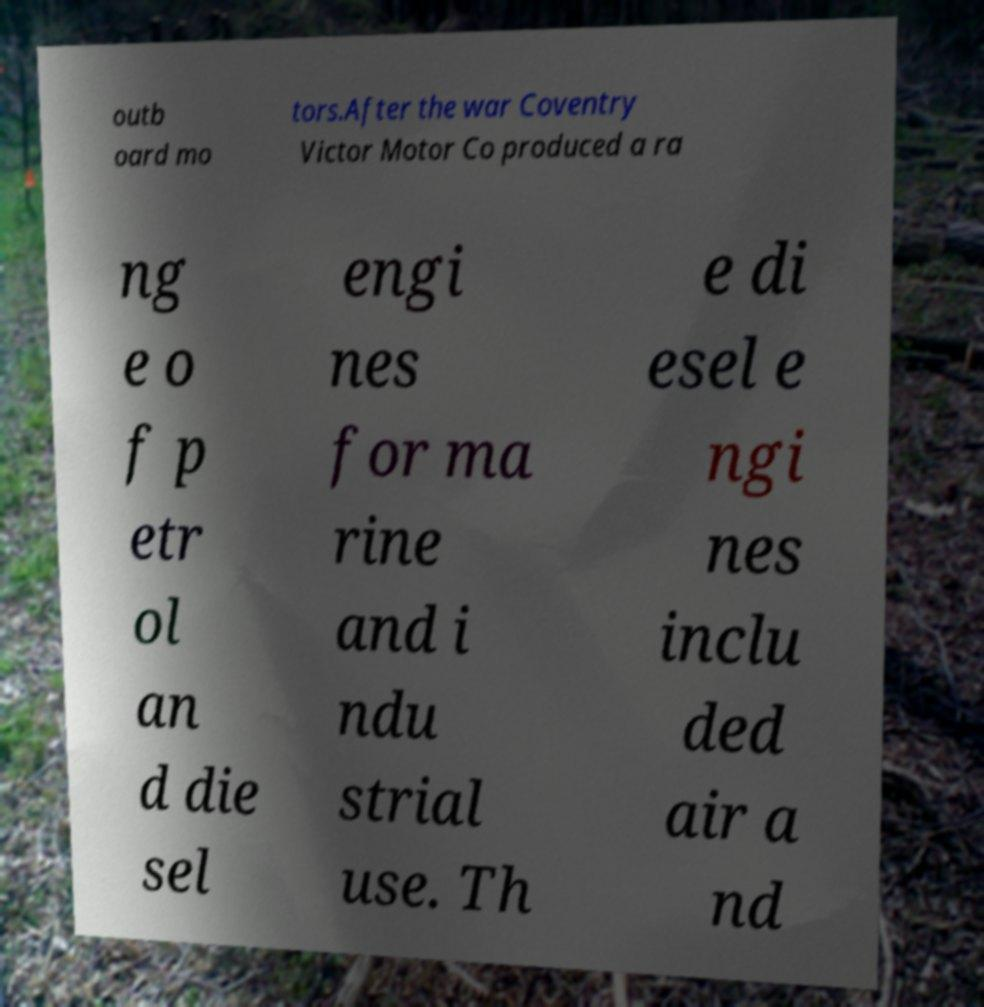For documentation purposes, I need the text within this image transcribed. Could you provide that? outb oard mo tors.After the war Coventry Victor Motor Co produced a ra ng e o f p etr ol an d die sel engi nes for ma rine and i ndu strial use. Th e di esel e ngi nes inclu ded air a nd 